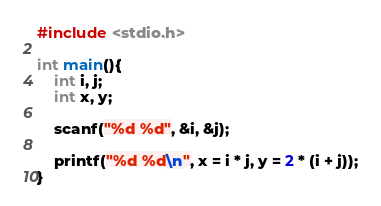<code> <loc_0><loc_0><loc_500><loc_500><_C_>#include <stdio.h>

int main(){
    int i, j;
    int x, y;

    scanf("%d %d", &i, &j);

    printf("%d %d\n", x = i * j, y = 2 * (i + j));
}
</code> 